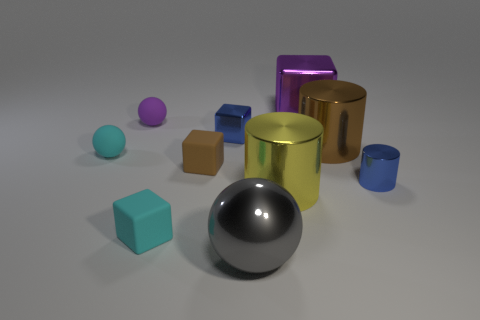The brown cube has what size?
Your response must be concise. Small. What size is the purple rubber object that is the same shape as the large gray metal object?
Make the answer very short. Small. There is a blue cylinder; how many large purple metallic cubes are on the right side of it?
Provide a succinct answer. 0. What is the color of the tiny metallic object on the left side of the small blue object that is right of the shiny ball?
Offer a terse response. Blue. Are there the same number of tiny blue shiny things that are to the left of the shiny ball and small shiny objects that are in front of the small blue cylinder?
Keep it short and to the point. No. What number of cylinders are either brown things or big purple shiny objects?
Offer a terse response. 1. What number of other objects are the same material as the yellow cylinder?
Provide a short and direct response. 5. There is a small object to the right of the brown cylinder; what shape is it?
Provide a succinct answer. Cylinder. What is the material of the purple object to the left of the cyan object that is in front of the brown rubber thing?
Your answer should be compact. Rubber. Is the number of things right of the cyan rubber block greater than the number of tiny brown shiny cylinders?
Give a very brief answer. Yes. 